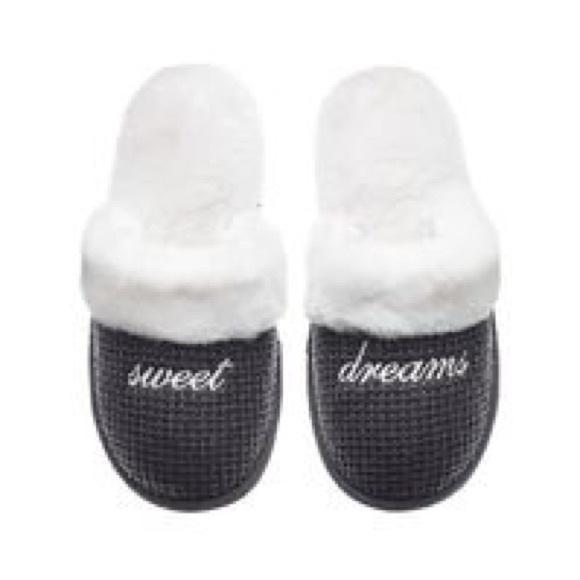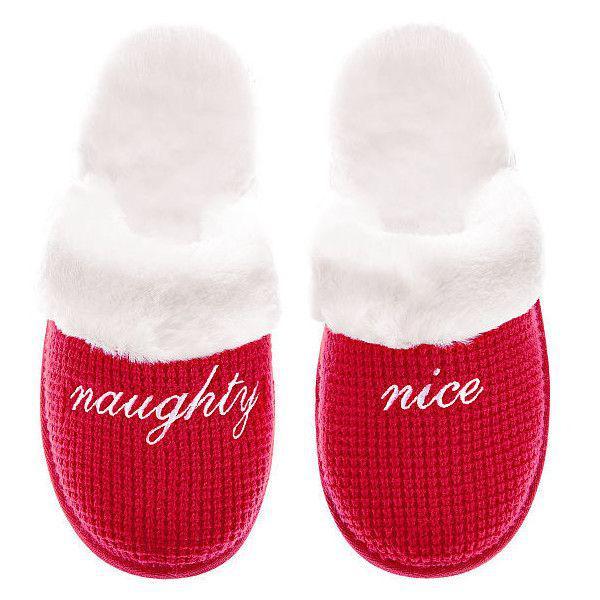The first image is the image on the left, the second image is the image on the right. Given the left and right images, does the statement "The left image features a slipper style with an animal face on the top, and the right image shows a matching pair of fur-trimmed slippers." hold true? Answer yes or no. No. The first image is the image on the left, the second image is the image on the right. For the images displayed, is the sentence "Two pairs of slippers are pink, but different styles, one of them a solid pink color with same color furry trim element." factually correct? Answer yes or no. No. 